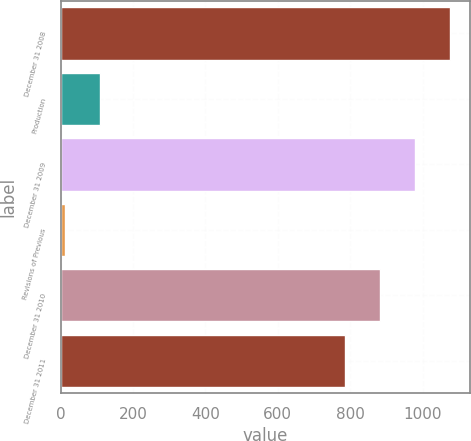<chart> <loc_0><loc_0><loc_500><loc_500><bar_chart><fcel>December 31 2008<fcel>Production<fcel>December 31 2009<fcel>Revisions of Previous<fcel>December 31 2010<fcel>December 31 2011<nl><fcel>1075.8<fcel>108.6<fcel>979.2<fcel>12<fcel>882.6<fcel>786<nl></chart> 